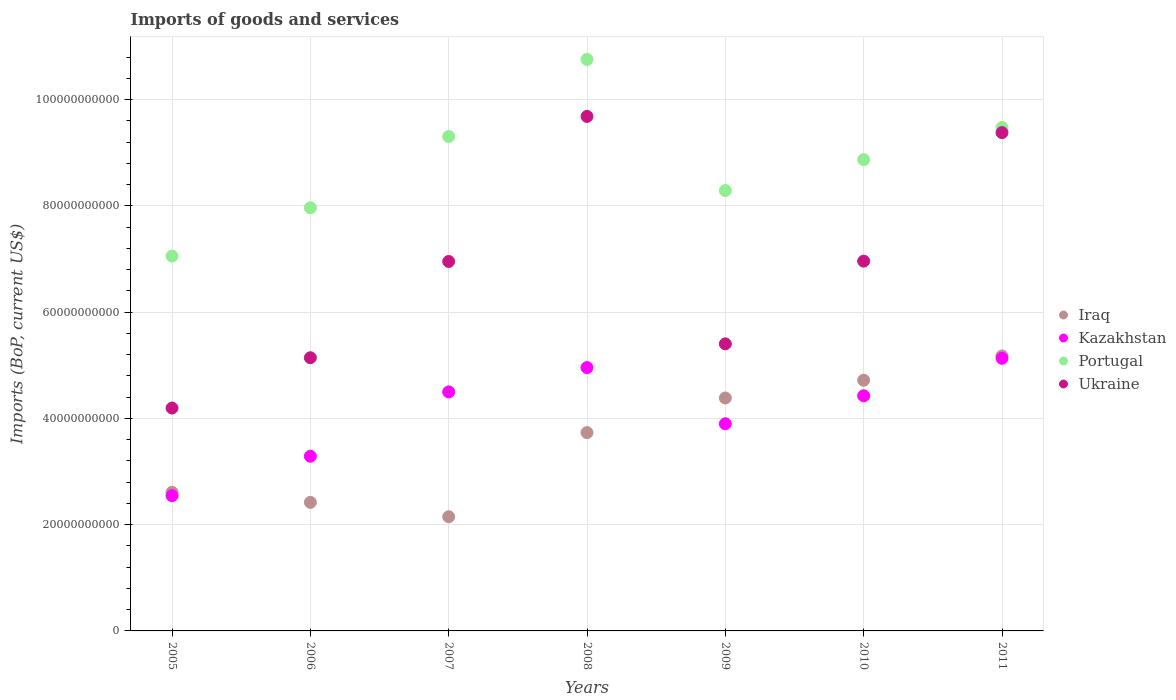How many different coloured dotlines are there?
Ensure brevity in your answer.  4. What is the amount spent on imports in Ukraine in 2008?
Your answer should be very brief. 9.68e+1. Across all years, what is the maximum amount spent on imports in Ukraine?
Your answer should be very brief. 9.68e+1. Across all years, what is the minimum amount spent on imports in Iraq?
Provide a short and direct response. 2.15e+1. In which year was the amount spent on imports in Portugal maximum?
Provide a succinct answer. 2008. In which year was the amount spent on imports in Kazakhstan minimum?
Keep it short and to the point. 2005. What is the total amount spent on imports in Kazakhstan in the graph?
Your response must be concise. 2.87e+11. What is the difference between the amount spent on imports in Kazakhstan in 2007 and that in 2008?
Your response must be concise. -4.58e+09. What is the difference between the amount spent on imports in Portugal in 2005 and the amount spent on imports in Ukraine in 2007?
Make the answer very short. 1.01e+09. What is the average amount spent on imports in Iraq per year?
Your answer should be compact. 3.60e+1. In the year 2008, what is the difference between the amount spent on imports in Iraq and amount spent on imports in Kazakhstan?
Give a very brief answer. -1.22e+1. What is the ratio of the amount spent on imports in Iraq in 2008 to that in 2009?
Ensure brevity in your answer.  0.85. What is the difference between the highest and the second highest amount spent on imports in Ukraine?
Keep it short and to the point. 3.05e+09. What is the difference between the highest and the lowest amount spent on imports in Iraq?
Your answer should be very brief. 3.03e+1. Is the sum of the amount spent on imports in Portugal in 2005 and 2010 greater than the maximum amount spent on imports in Iraq across all years?
Offer a very short reply. Yes. Does the amount spent on imports in Ukraine monotonically increase over the years?
Your answer should be very brief. No. How many dotlines are there?
Ensure brevity in your answer.  4. How many years are there in the graph?
Your response must be concise. 7. Are the values on the major ticks of Y-axis written in scientific E-notation?
Offer a very short reply. No. Does the graph contain grids?
Your response must be concise. Yes. How many legend labels are there?
Offer a very short reply. 4. What is the title of the graph?
Ensure brevity in your answer.  Imports of goods and services. Does "Cambodia" appear as one of the legend labels in the graph?
Provide a succinct answer. No. What is the label or title of the Y-axis?
Your answer should be very brief. Imports (BoP, current US$). What is the Imports (BoP, current US$) in Iraq in 2005?
Make the answer very short. 2.61e+1. What is the Imports (BoP, current US$) of Kazakhstan in 2005?
Offer a very short reply. 2.55e+1. What is the Imports (BoP, current US$) in Portugal in 2005?
Keep it short and to the point. 7.05e+1. What is the Imports (BoP, current US$) in Ukraine in 2005?
Offer a terse response. 4.20e+1. What is the Imports (BoP, current US$) of Iraq in 2006?
Offer a very short reply. 2.42e+1. What is the Imports (BoP, current US$) in Kazakhstan in 2006?
Provide a succinct answer. 3.29e+1. What is the Imports (BoP, current US$) of Portugal in 2006?
Provide a succinct answer. 7.96e+1. What is the Imports (BoP, current US$) of Ukraine in 2006?
Your answer should be very brief. 5.14e+1. What is the Imports (BoP, current US$) of Iraq in 2007?
Your answer should be compact. 2.15e+1. What is the Imports (BoP, current US$) in Kazakhstan in 2007?
Keep it short and to the point. 4.50e+1. What is the Imports (BoP, current US$) of Portugal in 2007?
Provide a short and direct response. 9.31e+1. What is the Imports (BoP, current US$) in Ukraine in 2007?
Your answer should be compact. 6.95e+1. What is the Imports (BoP, current US$) of Iraq in 2008?
Ensure brevity in your answer.  3.73e+1. What is the Imports (BoP, current US$) of Kazakhstan in 2008?
Offer a very short reply. 4.96e+1. What is the Imports (BoP, current US$) of Portugal in 2008?
Give a very brief answer. 1.08e+11. What is the Imports (BoP, current US$) of Ukraine in 2008?
Keep it short and to the point. 9.68e+1. What is the Imports (BoP, current US$) in Iraq in 2009?
Provide a short and direct response. 4.38e+1. What is the Imports (BoP, current US$) of Kazakhstan in 2009?
Make the answer very short. 3.90e+1. What is the Imports (BoP, current US$) in Portugal in 2009?
Provide a short and direct response. 8.29e+1. What is the Imports (BoP, current US$) in Ukraine in 2009?
Your answer should be very brief. 5.40e+1. What is the Imports (BoP, current US$) of Iraq in 2010?
Your response must be concise. 4.72e+1. What is the Imports (BoP, current US$) of Kazakhstan in 2010?
Ensure brevity in your answer.  4.43e+1. What is the Imports (BoP, current US$) in Portugal in 2010?
Offer a very short reply. 8.87e+1. What is the Imports (BoP, current US$) of Ukraine in 2010?
Keep it short and to the point. 6.96e+1. What is the Imports (BoP, current US$) of Iraq in 2011?
Keep it short and to the point. 5.18e+1. What is the Imports (BoP, current US$) of Kazakhstan in 2011?
Offer a very short reply. 5.13e+1. What is the Imports (BoP, current US$) of Portugal in 2011?
Ensure brevity in your answer.  9.48e+1. What is the Imports (BoP, current US$) of Ukraine in 2011?
Your answer should be compact. 9.38e+1. Across all years, what is the maximum Imports (BoP, current US$) in Iraq?
Provide a short and direct response. 5.18e+1. Across all years, what is the maximum Imports (BoP, current US$) of Kazakhstan?
Provide a succinct answer. 5.13e+1. Across all years, what is the maximum Imports (BoP, current US$) of Portugal?
Your answer should be very brief. 1.08e+11. Across all years, what is the maximum Imports (BoP, current US$) in Ukraine?
Your answer should be compact. 9.68e+1. Across all years, what is the minimum Imports (BoP, current US$) in Iraq?
Provide a short and direct response. 2.15e+1. Across all years, what is the minimum Imports (BoP, current US$) of Kazakhstan?
Ensure brevity in your answer.  2.55e+1. Across all years, what is the minimum Imports (BoP, current US$) in Portugal?
Make the answer very short. 7.05e+1. Across all years, what is the minimum Imports (BoP, current US$) of Ukraine?
Your answer should be compact. 4.20e+1. What is the total Imports (BoP, current US$) in Iraq in the graph?
Offer a terse response. 2.52e+11. What is the total Imports (BoP, current US$) in Kazakhstan in the graph?
Keep it short and to the point. 2.87e+11. What is the total Imports (BoP, current US$) of Portugal in the graph?
Offer a very short reply. 6.17e+11. What is the total Imports (BoP, current US$) in Ukraine in the graph?
Keep it short and to the point. 4.77e+11. What is the difference between the Imports (BoP, current US$) of Iraq in 2005 and that in 2006?
Keep it short and to the point. 1.90e+09. What is the difference between the Imports (BoP, current US$) of Kazakhstan in 2005 and that in 2006?
Offer a terse response. -7.42e+09. What is the difference between the Imports (BoP, current US$) of Portugal in 2005 and that in 2006?
Provide a short and direct response. -9.10e+09. What is the difference between the Imports (BoP, current US$) in Ukraine in 2005 and that in 2006?
Your answer should be very brief. -9.47e+09. What is the difference between the Imports (BoP, current US$) of Iraq in 2005 and that in 2007?
Keep it short and to the point. 4.61e+09. What is the difference between the Imports (BoP, current US$) of Kazakhstan in 2005 and that in 2007?
Your answer should be very brief. -1.95e+1. What is the difference between the Imports (BoP, current US$) in Portugal in 2005 and that in 2007?
Provide a short and direct response. -2.25e+1. What is the difference between the Imports (BoP, current US$) of Ukraine in 2005 and that in 2007?
Keep it short and to the point. -2.76e+1. What is the difference between the Imports (BoP, current US$) in Iraq in 2005 and that in 2008?
Ensure brevity in your answer.  -1.12e+1. What is the difference between the Imports (BoP, current US$) of Kazakhstan in 2005 and that in 2008?
Offer a very short reply. -2.41e+1. What is the difference between the Imports (BoP, current US$) in Portugal in 2005 and that in 2008?
Keep it short and to the point. -3.70e+1. What is the difference between the Imports (BoP, current US$) in Ukraine in 2005 and that in 2008?
Offer a terse response. -5.49e+1. What is the difference between the Imports (BoP, current US$) in Iraq in 2005 and that in 2009?
Your response must be concise. -1.78e+1. What is the difference between the Imports (BoP, current US$) of Kazakhstan in 2005 and that in 2009?
Provide a short and direct response. -1.35e+1. What is the difference between the Imports (BoP, current US$) of Portugal in 2005 and that in 2009?
Provide a succinct answer. -1.23e+1. What is the difference between the Imports (BoP, current US$) in Ukraine in 2005 and that in 2009?
Make the answer very short. -1.21e+1. What is the difference between the Imports (BoP, current US$) of Iraq in 2005 and that in 2010?
Offer a terse response. -2.11e+1. What is the difference between the Imports (BoP, current US$) in Kazakhstan in 2005 and that in 2010?
Give a very brief answer. -1.88e+1. What is the difference between the Imports (BoP, current US$) of Portugal in 2005 and that in 2010?
Ensure brevity in your answer.  -1.82e+1. What is the difference between the Imports (BoP, current US$) in Ukraine in 2005 and that in 2010?
Provide a succinct answer. -2.77e+1. What is the difference between the Imports (BoP, current US$) in Iraq in 2005 and that in 2011?
Your answer should be compact. -2.57e+1. What is the difference between the Imports (BoP, current US$) in Kazakhstan in 2005 and that in 2011?
Give a very brief answer. -2.59e+1. What is the difference between the Imports (BoP, current US$) of Portugal in 2005 and that in 2011?
Provide a short and direct response. -2.42e+1. What is the difference between the Imports (BoP, current US$) of Ukraine in 2005 and that in 2011?
Provide a short and direct response. -5.18e+1. What is the difference between the Imports (BoP, current US$) in Iraq in 2006 and that in 2007?
Your response must be concise. 2.71e+09. What is the difference between the Imports (BoP, current US$) in Kazakhstan in 2006 and that in 2007?
Keep it short and to the point. -1.21e+1. What is the difference between the Imports (BoP, current US$) of Portugal in 2006 and that in 2007?
Make the answer very short. -1.34e+1. What is the difference between the Imports (BoP, current US$) of Ukraine in 2006 and that in 2007?
Provide a short and direct response. -1.81e+1. What is the difference between the Imports (BoP, current US$) of Iraq in 2006 and that in 2008?
Your answer should be compact. -1.31e+1. What is the difference between the Imports (BoP, current US$) of Kazakhstan in 2006 and that in 2008?
Give a very brief answer. -1.67e+1. What is the difference between the Imports (BoP, current US$) in Portugal in 2006 and that in 2008?
Make the answer very short. -2.79e+1. What is the difference between the Imports (BoP, current US$) of Ukraine in 2006 and that in 2008?
Make the answer very short. -4.54e+1. What is the difference between the Imports (BoP, current US$) of Iraq in 2006 and that in 2009?
Ensure brevity in your answer.  -1.97e+1. What is the difference between the Imports (BoP, current US$) of Kazakhstan in 2006 and that in 2009?
Your answer should be compact. -6.12e+09. What is the difference between the Imports (BoP, current US$) in Portugal in 2006 and that in 2009?
Give a very brief answer. -3.25e+09. What is the difference between the Imports (BoP, current US$) in Ukraine in 2006 and that in 2009?
Your answer should be very brief. -2.61e+09. What is the difference between the Imports (BoP, current US$) of Iraq in 2006 and that in 2010?
Provide a succinct answer. -2.30e+1. What is the difference between the Imports (BoP, current US$) of Kazakhstan in 2006 and that in 2010?
Your answer should be very brief. -1.14e+1. What is the difference between the Imports (BoP, current US$) of Portugal in 2006 and that in 2010?
Ensure brevity in your answer.  -9.06e+09. What is the difference between the Imports (BoP, current US$) of Ukraine in 2006 and that in 2010?
Provide a succinct answer. -1.82e+1. What is the difference between the Imports (BoP, current US$) of Iraq in 2006 and that in 2011?
Keep it short and to the point. -2.76e+1. What is the difference between the Imports (BoP, current US$) of Kazakhstan in 2006 and that in 2011?
Keep it short and to the point. -1.84e+1. What is the difference between the Imports (BoP, current US$) of Portugal in 2006 and that in 2011?
Offer a terse response. -1.51e+1. What is the difference between the Imports (BoP, current US$) in Ukraine in 2006 and that in 2011?
Your answer should be very brief. -4.24e+1. What is the difference between the Imports (BoP, current US$) of Iraq in 2007 and that in 2008?
Your response must be concise. -1.58e+1. What is the difference between the Imports (BoP, current US$) of Kazakhstan in 2007 and that in 2008?
Your response must be concise. -4.58e+09. What is the difference between the Imports (BoP, current US$) of Portugal in 2007 and that in 2008?
Offer a terse response. -1.45e+1. What is the difference between the Imports (BoP, current US$) of Ukraine in 2007 and that in 2008?
Offer a terse response. -2.73e+1. What is the difference between the Imports (BoP, current US$) in Iraq in 2007 and that in 2009?
Make the answer very short. -2.24e+1. What is the difference between the Imports (BoP, current US$) in Kazakhstan in 2007 and that in 2009?
Your answer should be very brief. 5.99e+09. What is the difference between the Imports (BoP, current US$) of Portugal in 2007 and that in 2009?
Keep it short and to the point. 1.02e+1. What is the difference between the Imports (BoP, current US$) of Ukraine in 2007 and that in 2009?
Your response must be concise. 1.55e+1. What is the difference between the Imports (BoP, current US$) in Iraq in 2007 and that in 2010?
Your response must be concise. -2.57e+1. What is the difference between the Imports (BoP, current US$) of Kazakhstan in 2007 and that in 2010?
Make the answer very short. 7.30e+08. What is the difference between the Imports (BoP, current US$) in Portugal in 2007 and that in 2010?
Your answer should be very brief. 4.36e+09. What is the difference between the Imports (BoP, current US$) of Ukraine in 2007 and that in 2010?
Ensure brevity in your answer.  -6.50e+07. What is the difference between the Imports (BoP, current US$) in Iraq in 2007 and that in 2011?
Offer a very short reply. -3.03e+1. What is the difference between the Imports (BoP, current US$) in Kazakhstan in 2007 and that in 2011?
Offer a terse response. -6.33e+09. What is the difference between the Imports (BoP, current US$) of Portugal in 2007 and that in 2011?
Your response must be concise. -1.70e+09. What is the difference between the Imports (BoP, current US$) in Ukraine in 2007 and that in 2011?
Make the answer very short. -2.43e+1. What is the difference between the Imports (BoP, current US$) in Iraq in 2008 and that in 2009?
Provide a succinct answer. -6.51e+09. What is the difference between the Imports (BoP, current US$) in Kazakhstan in 2008 and that in 2009?
Your answer should be very brief. 1.06e+1. What is the difference between the Imports (BoP, current US$) of Portugal in 2008 and that in 2009?
Make the answer very short. 2.47e+1. What is the difference between the Imports (BoP, current US$) in Ukraine in 2008 and that in 2009?
Give a very brief answer. 4.28e+1. What is the difference between the Imports (BoP, current US$) in Iraq in 2008 and that in 2010?
Provide a succinct answer. -9.86e+09. What is the difference between the Imports (BoP, current US$) of Kazakhstan in 2008 and that in 2010?
Your response must be concise. 5.31e+09. What is the difference between the Imports (BoP, current US$) of Portugal in 2008 and that in 2010?
Your response must be concise. 1.89e+1. What is the difference between the Imports (BoP, current US$) of Ukraine in 2008 and that in 2010?
Your answer should be compact. 2.72e+1. What is the difference between the Imports (BoP, current US$) of Iraq in 2008 and that in 2011?
Your response must be concise. -1.44e+1. What is the difference between the Imports (BoP, current US$) of Kazakhstan in 2008 and that in 2011?
Your answer should be very brief. -1.75e+09. What is the difference between the Imports (BoP, current US$) in Portugal in 2008 and that in 2011?
Make the answer very short. 1.28e+1. What is the difference between the Imports (BoP, current US$) of Ukraine in 2008 and that in 2011?
Offer a terse response. 3.05e+09. What is the difference between the Imports (BoP, current US$) of Iraq in 2009 and that in 2010?
Offer a terse response. -3.34e+09. What is the difference between the Imports (BoP, current US$) in Kazakhstan in 2009 and that in 2010?
Your answer should be compact. -5.26e+09. What is the difference between the Imports (BoP, current US$) in Portugal in 2009 and that in 2010?
Keep it short and to the point. -5.81e+09. What is the difference between the Imports (BoP, current US$) in Ukraine in 2009 and that in 2010?
Give a very brief answer. -1.56e+1. What is the difference between the Imports (BoP, current US$) of Iraq in 2009 and that in 2011?
Keep it short and to the point. -7.91e+09. What is the difference between the Imports (BoP, current US$) of Kazakhstan in 2009 and that in 2011?
Keep it short and to the point. -1.23e+1. What is the difference between the Imports (BoP, current US$) in Portugal in 2009 and that in 2011?
Provide a short and direct response. -1.19e+1. What is the difference between the Imports (BoP, current US$) of Ukraine in 2009 and that in 2011?
Your answer should be very brief. -3.98e+1. What is the difference between the Imports (BoP, current US$) of Iraq in 2010 and that in 2011?
Provide a succinct answer. -4.57e+09. What is the difference between the Imports (BoP, current US$) in Kazakhstan in 2010 and that in 2011?
Provide a short and direct response. -7.06e+09. What is the difference between the Imports (BoP, current US$) of Portugal in 2010 and that in 2011?
Make the answer very short. -6.06e+09. What is the difference between the Imports (BoP, current US$) in Ukraine in 2010 and that in 2011?
Make the answer very short. -2.42e+1. What is the difference between the Imports (BoP, current US$) in Iraq in 2005 and the Imports (BoP, current US$) in Kazakhstan in 2006?
Give a very brief answer. -6.78e+09. What is the difference between the Imports (BoP, current US$) of Iraq in 2005 and the Imports (BoP, current US$) of Portugal in 2006?
Your answer should be compact. -5.36e+1. What is the difference between the Imports (BoP, current US$) of Iraq in 2005 and the Imports (BoP, current US$) of Ukraine in 2006?
Keep it short and to the point. -2.53e+1. What is the difference between the Imports (BoP, current US$) in Kazakhstan in 2005 and the Imports (BoP, current US$) in Portugal in 2006?
Your response must be concise. -5.42e+1. What is the difference between the Imports (BoP, current US$) in Kazakhstan in 2005 and the Imports (BoP, current US$) in Ukraine in 2006?
Provide a short and direct response. -2.60e+1. What is the difference between the Imports (BoP, current US$) of Portugal in 2005 and the Imports (BoP, current US$) of Ukraine in 2006?
Keep it short and to the point. 1.91e+1. What is the difference between the Imports (BoP, current US$) in Iraq in 2005 and the Imports (BoP, current US$) in Kazakhstan in 2007?
Your answer should be very brief. -1.89e+1. What is the difference between the Imports (BoP, current US$) of Iraq in 2005 and the Imports (BoP, current US$) of Portugal in 2007?
Provide a succinct answer. -6.70e+1. What is the difference between the Imports (BoP, current US$) of Iraq in 2005 and the Imports (BoP, current US$) of Ukraine in 2007?
Offer a terse response. -4.34e+1. What is the difference between the Imports (BoP, current US$) of Kazakhstan in 2005 and the Imports (BoP, current US$) of Portugal in 2007?
Your answer should be compact. -6.76e+1. What is the difference between the Imports (BoP, current US$) of Kazakhstan in 2005 and the Imports (BoP, current US$) of Ukraine in 2007?
Keep it short and to the point. -4.41e+1. What is the difference between the Imports (BoP, current US$) in Portugal in 2005 and the Imports (BoP, current US$) in Ukraine in 2007?
Provide a succinct answer. 1.01e+09. What is the difference between the Imports (BoP, current US$) of Iraq in 2005 and the Imports (BoP, current US$) of Kazakhstan in 2008?
Give a very brief answer. -2.35e+1. What is the difference between the Imports (BoP, current US$) in Iraq in 2005 and the Imports (BoP, current US$) in Portugal in 2008?
Your answer should be very brief. -8.15e+1. What is the difference between the Imports (BoP, current US$) of Iraq in 2005 and the Imports (BoP, current US$) of Ukraine in 2008?
Keep it short and to the point. -7.08e+1. What is the difference between the Imports (BoP, current US$) of Kazakhstan in 2005 and the Imports (BoP, current US$) of Portugal in 2008?
Ensure brevity in your answer.  -8.21e+1. What is the difference between the Imports (BoP, current US$) of Kazakhstan in 2005 and the Imports (BoP, current US$) of Ukraine in 2008?
Your answer should be very brief. -7.14e+1. What is the difference between the Imports (BoP, current US$) in Portugal in 2005 and the Imports (BoP, current US$) in Ukraine in 2008?
Make the answer very short. -2.63e+1. What is the difference between the Imports (BoP, current US$) in Iraq in 2005 and the Imports (BoP, current US$) in Kazakhstan in 2009?
Give a very brief answer. -1.29e+1. What is the difference between the Imports (BoP, current US$) of Iraq in 2005 and the Imports (BoP, current US$) of Portugal in 2009?
Make the answer very short. -5.68e+1. What is the difference between the Imports (BoP, current US$) in Iraq in 2005 and the Imports (BoP, current US$) in Ukraine in 2009?
Offer a terse response. -2.79e+1. What is the difference between the Imports (BoP, current US$) in Kazakhstan in 2005 and the Imports (BoP, current US$) in Portugal in 2009?
Your response must be concise. -5.74e+1. What is the difference between the Imports (BoP, current US$) in Kazakhstan in 2005 and the Imports (BoP, current US$) in Ukraine in 2009?
Keep it short and to the point. -2.86e+1. What is the difference between the Imports (BoP, current US$) of Portugal in 2005 and the Imports (BoP, current US$) of Ukraine in 2009?
Offer a terse response. 1.65e+1. What is the difference between the Imports (BoP, current US$) in Iraq in 2005 and the Imports (BoP, current US$) in Kazakhstan in 2010?
Provide a succinct answer. -1.82e+1. What is the difference between the Imports (BoP, current US$) in Iraq in 2005 and the Imports (BoP, current US$) in Portugal in 2010?
Your response must be concise. -6.26e+1. What is the difference between the Imports (BoP, current US$) in Iraq in 2005 and the Imports (BoP, current US$) in Ukraine in 2010?
Give a very brief answer. -4.35e+1. What is the difference between the Imports (BoP, current US$) of Kazakhstan in 2005 and the Imports (BoP, current US$) of Portugal in 2010?
Your answer should be compact. -6.33e+1. What is the difference between the Imports (BoP, current US$) of Kazakhstan in 2005 and the Imports (BoP, current US$) of Ukraine in 2010?
Give a very brief answer. -4.41e+1. What is the difference between the Imports (BoP, current US$) of Portugal in 2005 and the Imports (BoP, current US$) of Ukraine in 2010?
Give a very brief answer. 9.42e+08. What is the difference between the Imports (BoP, current US$) of Iraq in 2005 and the Imports (BoP, current US$) of Kazakhstan in 2011?
Your answer should be very brief. -2.52e+1. What is the difference between the Imports (BoP, current US$) of Iraq in 2005 and the Imports (BoP, current US$) of Portugal in 2011?
Your response must be concise. -6.87e+1. What is the difference between the Imports (BoP, current US$) of Iraq in 2005 and the Imports (BoP, current US$) of Ukraine in 2011?
Your answer should be very brief. -6.77e+1. What is the difference between the Imports (BoP, current US$) of Kazakhstan in 2005 and the Imports (BoP, current US$) of Portugal in 2011?
Offer a very short reply. -6.93e+1. What is the difference between the Imports (BoP, current US$) in Kazakhstan in 2005 and the Imports (BoP, current US$) in Ukraine in 2011?
Provide a short and direct response. -6.83e+1. What is the difference between the Imports (BoP, current US$) in Portugal in 2005 and the Imports (BoP, current US$) in Ukraine in 2011?
Give a very brief answer. -2.32e+1. What is the difference between the Imports (BoP, current US$) in Iraq in 2006 and the Imports (BoP, current US$) in Kazakhstan in 2007?
Provide a short and direct response. -2.08e+1. What is the difference between the Imports (BoP, current US$) of Iraq in 2006 and the Imports (BoP, current US$) of Portugal in 2007?
Your answer should be compact. -6.89e+1. What is the difference between the Imports (BoP, current US$) of Iraq in 2006 and the Imports (BoP, current US$) of Ukraine in 2007?
Provide a succinct answer. -4.53e+1. What is the difference between the Imports (BoP, current US$) of Kazakhstan in 2006 and the Imports (BoP, current US$) of Portugal in 2007?
Provide a short and direct response. -6.02e+1. What is the difference between the Imports (BoP, current US$) in Kazakhstan in 2006 and the Imports (BoP, current US$) in Ukraine in 2007?
Ensure brevity in your answer.  -3.67e+1. What is the difference between the Imports (BoP, current US$) in Portugal in 2006 and the Imports (BoP, current US$) in Ukraine in 2007?
Your answer should be compact. 1.01e+1. What is the difference between the Imports (BoP, current US$) of Iraq in 2006 and the Imports (BoP, current US$) of Kazakhstan in 2008?
Keep it short and to the point. -2.54e+1. What is the difference between the Imports (BoP, current US$) in Iraq in 2006 and the Imports (BoP, current US$) in Portugal in 2008?
Offer a terse response. -8.34e+1. What is the difference between the Imports (BoP, current US$) of Iraq in 2006 and the Imports (BoP, current US$) of Ukraine in 2008?
Provide a short and direct response. -7.27e+1. What is the difference between the Imports (BoP, current US$) in Kazakhstan in 2006 and the Imports (BoP, current US$) in Portugal in 2008?
Make the answer very short. -7.47e+1. What is the difference between the Imports (BoP, current US$) in Kazakhstan in 2006 and the Imports (BoP, current US$) in Ukraine in 2008?
Make the answer very short. -6.40e+1. What is the difference between the Imports (BoP, current US$) of Portugal in 2006 and the Imports (BoP, current US$) of Ukraine in 2008?
Offer a very short reply. -1.72e+1. What is the difference between the Imports (BoP, current US$) of Iraq in 2006 and the Imports (BoP, current US$) of Kazakhstan in 2009?
Keep it short and to the point. -1.48e+1. What is the difference between the Imports (BoP, current US$) in Iraq in 2006 and the Imports (BoP, current US$) in Portugal in 2009?
Keep it short and to the point. -5.87e+1. What is the difference between the Imports (BoP, current US$) in Iraq in 2006 and the Imports (BoP, current US$) in Ukraine in 2009?
Provide a short and direct response. -2.98e+1. What is the difference between the Imports (BoP, current US$) in Kazakhstan in 2006 and the Imports (BoP, current US$) in Portugal in 2009?
Your answer should be compact. -5.00e+1. What is the difference between the Imports (BoP, current US$) of Kazakhstan in 2006 and the Imports (BoP, current US$) of Ukraine in 2009?
Provide a succinct answer. -2.12e+1. What is the difference between the Imports (BoP, current US$) in Portugal in 2006 and the Imports (BoP, current US$) in Ukraine in 2009?
Provide a short and direct response. 2.56e+1. What is the difference between the Imports (BoP, current US$) of Iraq in 2006 and the Imports (BoP, current US$) of Kazakhstan in 2010?
Provide a short and direct response. -2.01e+1. What is the difference between the Imports (BoP, current US$) in Iraq in 2006 and the Imports (BoP, current US$) in Portugal in 2010?
Provide a succinct answer. -6.45e+1. What is the difference between the Imports (BoP, current US$) in Iraq in 2006 and the Imports (BoP, current US$) in Ukraine in 2010?
Give a very brief answer. -4.54e+1. What is the difference between the Imports (BoP, current US$) in Kazakhstan in 2006 and the Imports (BoP, current US$) in Portugal in 2010?
Offer a very short reply. -5.58e+1. What is the difference between the Imports (BoP, current US$) of Kazakhstan in 2006 and the Imports (BoP, current US$) of Ukraine in 2010?
Provide a short and direct response. -3.67e+1. What is the difference between the Imports (BoP, current US$) of Portugal in 2006 and the Imports (BoP, current US$) of Ukraine in 2010?
Keep it short and to the point. 1.00e+1. What is the difference between the Imports (BoP, current US$) in Iraq in 2006 and the Imports (BoP, current US$) in Kazakhstan in 2011?
Your answer should be compact. -2.71e+1. What is the difference between the Imports (BoP, current US$) of Iraq in 2006 and the Imports (BoP, current US$) of Portugal in 2011?
Provide a succinct answer. -7.06e+1. What is the difference between the Imports (BoP, current US$) of Iraq in 2006 and the Imports (BoP, current US$) of Ukraine in 2011?
Your answer should be compact. -6.96e+1. What is the difference between the Imports (BoP, current US$) in Kazakhstan in 2006 and the Imports (BoP, current US$) in Portugal in 2011?
Your answer should be compact. -6.19e+1. What is the difference between the Imports (BoP, current US$) of Kazakhstan in 2006 and the Imports (BoP, current US$) of Ukraine in 2011?
Provide a short and direct response. -6.09e+1. What is the difference between the Imports (BoP, current US$) of Portugal in 2006 and the Imports (BoP, current US$) of Ukraine in 2011?
Offer a very short reply. -1.41e+1. What is the difference between the Imports (BoP, current US$) of Iraq in 2007 and the Imports (BoP, current US$) of Kazakhstan in 2008?
Provide a succinct answer. -2.81e+1. What is the difference between the Imports (BoP, current US$) in Iraq in 2007 and the Imports (BoP, current US$) in Portugal in 2008?
Make the answer very short. -8.61e+1. What is the difference between the Imports (BoP, current US$) of Iraq in 2007 and the Imports (BoP, current US$) of Ukraine in 2008?
Your response must be concise. -7.54e+1. What is the difference between the Imports (BoP, current US$) in Kazakhstan in 2007 and the Imports (BoP, current US$) in Portugal in 2008?
Provide a succinct answer. -6.26e+1. What is the difference between the Imports (BoP, current US$) in Kazakhstan in 2007 and the Imports (BoP, current US$) in Ukraine in 2008?
Your answer should be very brief. -5.19e+1. What is the difference between the Imports (BoP, current US$) in Portugal in 2007 and the Imports (BoP, current US$) in Ukraine in 2008?
Your response must be concise. -3.78e+09. What is the difference between the Imports (BoP, current US$) of Iraq in 2007 and the Imports (BoP, current US$) of Kazakhstan in 2009?
Offer a terse response. -1.75e+1. What is the difference between the Imports (BoP, current US$) of Iraq in 2007 and the Imports (BoP, current US$) of Portugal in 2009?
Your response must be concise. -6.14e+1. What is the difference between the Imports (BoP, current US$) of Iraq in 2007 and the Imports (BoP, current US$) of Ukraine in 2009?
Make the answer very short. -3.25e+1. What is the difference between the Imports (BoP, current US$) of Kazakhstan in 2007 and the Imports (BoP, current US$) of Portugal in 2009?
Keep it short and to the point. -3.79e+1. What is the difference between the Imports (BoP, current US$) of Kazakhstan in 2007 and the Imports (BoP, current US$) of Ukraine in 2009?
Offer a terse response. -9.05e+09. What is the difference between the Imports (BoP, current US$) in Portugal in 2007 and the Imports (BoP, current US$) in Ukraine in 2009?
Provide a short and direct response. 3.90e+1. What is the difference between the Imports (BoP, current US$) of Iraq in 2007 and the Imports (BoP, current US$) of Kazakhstan in 2010?
Your response must be concise. -2.28e+1. What is the difference between the Imports (BoP, current US$) in Iraq in 2007 and the Imports (BoP, current US$) in Portugal in 2010?
Provide a succinct answer. -6.72e+1. What is the difference between the Imports (BoP, current US$) in Iraq in 2007 and the Imports (BoP, current US$) in Ukraine in 2010?
Give a very brief answer. -4.81e+1. What is the difference between the Imports (BoP, current US$) in Kazakhstan in 2007 and the Imports (BoP, current US$) in Portugal in 2010?
Keep it short and to the point. -4.37e+1. What is the difference between the Imports (BoP, current US$) of Kazakhstan in 2007 and the Imports (BoP, current US$) of Ukraine in 2010?
Ensure brevity in your answer.  -2.46e+1. What is the difference between the Imports (BoP, current US$) of Portugal in 2007 and the Imports (BoP, current US$) of Ukraine in 2010?
Your answer should be compact. 2.35e+1. What is the difference between the Imports (BoP, current US$) of Iraq in 2007 and the Imports (BoP, current US$) of Kazakhstan in 2011?
Your response must be concise. -2.98e+1. What is the difference between the Imports (BoP, current US$) of Iraq in 2007 and the Imports (BoP, current US$) of Portugal in 2011?
Your answer should be compact. -7.33e+1. What is the difference between the Imports (BoP, current US$) in Iraq in 2007 and the Imports (BoP, current US$) in Ukraine in 2011?
Offer a terse response. -7.23e+1. What is the difference between the Imports (BoP, current US$) in Kazakhstan in 2007 and the Imports (BoP, current US$) in Portugal in 2011?
Your answer should be compact. -4.98e+1. What is the difference between the Imports (BoP, current US$) of Kazakhstan in 2007 and the Imports (BoP, current US$) of Ukraine in 2011?
Your response must be concise. -4.88e+1. What is the difference between the Imports (BoP, current US$) in Portugal in 2007 and the Imports (BoP, current US$) in Ukraine in 2011?
Offer a terse response. -7.29e+08. What is the difference between the Imports (BoP, current US$) in Iraq in 2008 and the Imports (BoP, current US$) in Kazakhstan in 2009?
Ensure brevity in your answer.  -1.67e+09. What is the difference between the Imports (BoP, current US$) of Iraq in 2008 and the Imports (BoP, current US$) of Portugal in 2009?
Your answer should be very brief. -4.56e+1. What is the difference between the Imports (BoP, current US$) of Iraq in 2008 and the Imports (BoP, current US$) of Ukraine in 2009?
Make the answer very short. -1.67e+1. What is the difference between the Imports (BoP, current US$) in Kazakhstan in 2008 and the Imports (BoP, current US$) in Portugal in 2009?
Offer a terse response. -3.33e+1. What is the difference between the Imports (BoP, current US$) in Kazakhstan in 2008 and the Imports (BoP, current US$) in Ukraine in 2009?
Provide a succinct answer. -4.47e+09. What is the difference between the Imports (BoP, current US$) in Portugal in 2008 and the Imports (BoP, current US$) in Ukraine in 2009?
Offer a very short reply. 5.35e+1. What is the difference between the Imports (BoP, current US$) of Iraq in 2008 and the Imports (BoP, current US$) of Kazakhstan in 2010?
Provide a short and direct response. -6.93e+09. What is the difference between the Imports (BoP, current US$) of Iraq in 2008 and the Imports (BoP, current US$) of Portugal in 2010?
Your answer should be compact. -5.14e+1. What is the difference between the Imports (BoP, current US$) of Iraq in 2008 and the Imports (BoP, current US$) of Ukraine in 2010?
Give a very brief answer. -3.23e+1. What is the difference between the Imports (BoP, current US$) in Kazakhstan in 2008 and the Imports (BoP, current US$) in Portugal in 2010?
Keep it short and to the point. -3.91e+1. What is the difference between the Imports (BoP, current US$) of Kazakhstan in 2008 and the Imports (BoP, current US$) of Ukraine in 2010?
Provide a succinct answer. -2.00e+1. What is the difference between the Imports (BoP, current US$) in Portugal in 2008 and the Imports (BoP, current US$) in Ukraine in 2010?
Offer a very short reply. 3.80e+1. What is the difference between the Imports (BoP, current US$) in Iraq in 2008 and the Imports (BoP, current US$) in Kazakhstan in 2011?
Provide a short and direct response. -1.40e+1. What is the difference between the Imports (BoP, current US$) of Iraq in 2008 and the Imports (BoP, current US$) of Portugal in 2011?
Offer a terse response. -5.74e+1. What is the difference between the Imports (BoP, current US$) of Iraq in 2008 and the Imports (BoP, current US$) of Ukraine in 2011?
Provide a succinct answer. -5.65e+1. What is the difference between the Imports (BoP, current US$) in Kazakhstan in 2008 and the Imports (BoP, current US$) in Portugal in 2011?
Provide a short and direct response. -4.52e+1. What is the difference between the Imports (BoP, current US$) in Kazakhstan in 2008 and the Imports (BoP, current US$) in Ukraine in 2011?
Ensure brevity in your answer.  -4.42e+1. What is the difference between the Imports (BoP, current US$) of Portugal in 2008 and the Imports (BoP, current US$) of Ukraine in 2011?
Provide a short and direct response. 1.38e+1. What is the difference between the Imports (BoP, current US$) of Iraq in 2009 and the Imports (BoP, current US$) of Kazakhstan in 2010?
Keep it short and to the point. -4.12e+08. What is the difference between the Imports (BoP, current US$) of Iraq in 2009 and the Imports (BoP, current US$) of Portugal in 2010?
Keep it short and to the point. -4.49e+1. What is the difference between the Imports (BoP, current US$) of Iraq in 2009 and the Imports (BoP, current US$) of Ukraine in 2010?
Your response must be concise. -2.58e+1. What is the difference between the Imports (BoP, current US$) of Kazakhstan in 2009 and the Imports (BoP, current US$) of Portugal in 2010?
Offer a terse response. -4.97e+1. What is the difference between the Imports (BoP, current US$) of Kazakhstan in 2009 and the Imports (BoP, current US$) of Ukraine in 2010?
Make the answer very short. -3.06e+1. What is the difference between the Imports (BoP, current US$) in Portugal in 2009 and the Imports (BoP, current US$) in Ukraine in 2010?
Give a very brief answer. 1.33e+1. What is the difference between the Imports (BoP, current US$) of Iraq in 2009 and the Imports (BoP, current US$) of Kazakhstan in 2011?
Offer a very short reply. -7.47e+09. What is the difference between the Imports (BoP, current US$) of Iraq in 2009 and the Imports (BoP, current US$) of Portugal in 2011?
Ensure brevity in your answer.  -5.09e+1. What is the difference between the Imports (BoP, current US$) in Iraq in 2009 and the Imports (BoP, current US$) in Ukraine in 2011?
Give a very brief answer. -4.99e+1. What is the difference between the Imports (BoP, current US$) in Kazakhstan in 2009 and the Imports (BoP, current US$) in Portugal in 2011?
Make the answer very short. -5.58e+1. What is the difference between the Imports (BoP, current US$) of Kazakhstan in 2009 and the Imports (BoP, current US$) of Ukraine in 2011?
Your answer should be compact. -5.48e+1. What is the difference between the Imports (BoP, current US$) in Portugal in 2009 and the Imports (BoP, current US$) in Ukraine in 2011?
Make the answer very short. -1.09e+1. What is the difference between the Imports (BoP, current US$) in Iraq in 2010 and the Imports (BoP, current US$) in Kazakhstan in 2011?
Make the answer very short. -4.13e+09. What is the difference between the Imports (BoP, current US$) in Iraq in 2010 and the Imports (BoP, current US$) in Portugal in 2011?
Your answer should be compact. -4.76e+1. What is the difference between the Imports (BoP, current US$) of Iraq in 2010 and the Imports (BoP, current US$) of Ukraine in 2011?
Offer a terse response. -4.66e+1. What is the difference between the Imports (BoP, current US$) in Kazakhstan in 2010 and the Imports (BoP, current US$) in Portugal in 2011?
Your response must be concise. -5.05e+1. What is the difference between the Imports (BoP, current US$) of Kazakhstan in 2010 and the Imports (BoP, current US$) of Ukraine in 2011?
Make the answer very short. -4.95e+1. What is the difference between the Imports (BoP, current US$) of Portugal in 2010 and the Imports (BoP, current US$) of Ukraine in 2011?
Give a very brief answer. -5.09e+09. What is the average Imports (BoP, current US$) of Iraq per year?
Ensure brevity in your answer.  3.60e+1. What is the average Imports (BoP, current US$) of Kazakhstan per year?
Give a very brief answer. 4.11e+1. What is the average Imports (BoP, current US$) in Portugal per year?
Your answer should be very brief. 8.82e+1. What is the average Imports (BoP, current US$) of Ukraine per year?
Keep it short and to the point. 6.82e+1. In the year 2005, what is the difference between the Imports (BoP, current US$) in Iraq and Imports (BoP, current US$) in Kazakhstan?
Keep it short and to the point. 6.38e+08. In the year 2005, what is the difference between the Imports (BoP, current US$) in Iraq and Imports (BoP, current US$) in Portugal?
Provide a short and direct response. -4.45e+1. In the year 2005, what is the difference between the Imports (BoP, current US$) in Iraq and Imports (BoP, current US$) in Ukraine?
Provide a succinct answer. -1.59e+1. In the year 2005, what is the difference between the Imports (BoP, current US$) of Kazakhstan and Imports (BoP, current US$) of Portugal?
Your answer should be compact. -4.51e+1. In the year 2005, what is the difference between the Imports (BoP, current US$) in Kazakhstan and Imports (BoP, current US$) in Ukraine?
Provide a succinct answer. -1.65e+1. In the year 2005, what is the difference between the Imports (BoP, current US$) of Portugal and Imports (BoP, current US$) of Ukraine?
Offer a very short reply. 2.86e+1. In the year 2006, what is the difference between the Imports (BoP, current US$) of Iraq and Imports (BoP, current US$) of Kazakhstan?
Make the answer very short. -8.68e+09. In the year 2006, what is the difference between the Imports (BoP, current US$) of Iraq and Imports (BoP, current US$) of Portugal?
Provide a short and direct response. -5.55e+1. In the year 2006, what is the difference between the Imports (BoP, current US$) of Iraq and Imports (BoP, current US$) of Ukraine?
Ensure brevity in your answer.  -2.72e+1. In the year 2006, what is the difference between the Imports (BoP, current US$) of Kazakhstan and Imports (BoP, current US$) of Portugal?
Make the answer very short. -4.68e+1. In the year 2006, what is the difference between the Imports (BoP, current US$) in Kazakhstan and Imports (BoP, current US$) in Ukraine?
Give a very brief answer. -1.85e+1. In the year 2006, what is the difference between the Imports (BoP, current US$) in Portugal and Imports (BoP, current US$) in Ukraine?
Your response must be concise. 2.82e+1. In the year 2007, what is the difference between the Imports (BoP, current US$) of Iraq and Imports (BoP, current US$) of Kazakhstan?
Give a very brief answer. -2.35e+1. In the year 2007, what is the difference between the Imports (BoP, current US$) in Iraq and Imports (BoP, current US$) in Portugal?
Provide a short and direct response. -7.16e+1. In the year 2007, what is the difference between the Imports (BoP, current US$) of Iraq and Imports (BoP, current US$) of Ukraine?
Give a very brief answer. -4.81e+1. In the year 2007, what is the difference between the Imports (BoP, current US$) of Kazakhstan and Imports (BoP, current US$) of Portugal?
Ensure brevity in your answer.  -4.81e+1. In the year 2007, what is the difference between the Imports (BoP, current US$) in Kazakhstan and Imports (BoP, current US$) in Ukraine?
Provide a short and direct response. -2.46e+1. In the year 2007, what is the difference between the Imports (BoP, current US$) in Portugal and Imports (BoP, current US$) in Ukraine?
Give a very brief answer. 2.35e+1. In the year 2008, what is the difference between the Imports (BoP, current US$) in Iraq and Imports (BoP, current US$) in Kazakhstan?
Give a very brief answer. -1.22e+1. In the year 2008, what is the difference between the Imports (BoP, current US$) of Iraq and Imports (BoP, current US$) of Portugal?
Make the answer very short. -7.02e+1. In the year 2008, what is the difference between the Imports (BoP, current US$) in Iraq and Imports (BoP, current US$) in Ukraine?
Make the answer very short. -5.95e+1. In the year 2008, what is the difference between the Imports (BoP, current US$) of Kazakhstan and Imports (BoP, current US$) of Portugal?
Make the answer very short. -5.80e+1. In the year 2008, what is the difference between the Imports (BoP, current US$) of Kazakhstan and Imports (BoP, current US$) of Ukraine?
Your answer should be compact. -4.73e+1. In the year 2008, what is the difference between the Imports (BoP, current US$) in Portugal and Imports (BoP, current US$) in Ukraine?
Offer a terse response. 1.07e+1. In the year 2009, what is the difference between the Imports (BoP, current US$) of Iraq and Imports (BoP, current US$) of Kazakhstan?
Your response must be concise. 4.85e+09. In the year 2009, what is the difference between the Imports (BoP, current US$) of Iraq and Imports (BoP, current US$) of Portugal?
Your answer should be compact. -3.90e+1. In the year 2009, what is the difference between the Imports (BoP, current US$) of Iraq and Imports (BoP, current US$) of Ukraine?
Provide a short and direct response. -1.02e+1. In the year 2009, what is the difference between the Imports (BoP, current US$) of Kazakhstan and Imports (BoP, current US$) of Portugal?
Your answer should be very brief. -4.39e+1. In the year 2009, what is the difference between the Imports (BoP, current US$) of Kazakhstan and Imports (BoP, current US$) of Ukraine?
Provide a short and direct response. -1.50e+1. In the year 2009, what is the difference between the Imports (BoP, current US$) in Portugal and Imports (BoP, current US$) in Ukraine?
Offer a terse response. 2.89e+1. In the year 2010, what is the difference between the Imports (BoP, current US$) of Iraq and Imports (BoP, current US$) of Kazakhstan?
Make the answer very short. 2.93e+09. In the year 2010, what is the difference between the Imports (BoP, current US$) in Iraq and Imports (BoP, current US$) in Portugal?
Your answer should be very brief. -4.15e+1. In the year 2010, what is the difference between the Imports (BoP, current US$) of Iraq and Imports (BoP, current US$) of Ukraine?
Give a very brief answer. -2.24e+1. In the year 2010, what is the difference between the Imports (BoP, current US$) of Kazakhstan and Imports (BoP, current US$) of Portugal?
Provide a short and direct response. -4.45e+1. In the year 2010, what is the difference between the Imports (BoP, current US$) of Kazakhstan and Imports (BoP, current US$) of Ukraine?
Ensure brevity in your answer.  -2.53e+1. In the year 2010, what is the difference between the Imports (BoP, current US$) of Portugal and Imports (BoP, current US$) of Ukraine?
Your answer should be very brief. 1.91e+1. In the year 2011, what is the difference between the Imports (BoP, current US$) of Iraq and Imports (BoP, current US$) of Kazakhstan?
Make the answer very short. 4.34e+08. In the year 2011, what is the difference between the Imports (BoP, current US$) of Iraq and Imports (BoP, current US$) of Portugal?
Ensure brevity in your answer.  -4.30e+1. In the year 2011, what is the difference between the Imports (BoP, current US$) in Iraq and Imports (BoP, current US$) in Ukraine?
Provide a short and direct response. -4.20e+1. In the year 2011, what is the difference between the Imports (BoP, current US$) of Kazakhstan and Imports (BoP, current US$) of Portugal?
Your answer should be very brief. -4.34e+1. In the year 2011, what is the difference between the Imports (BoP, current US$) in Kazakhstan and Imports (BoP, current US$) in Ukraine?
Ensure brevity in your answer.  -4.25e+1. In the year 2011, what is the difference between the Imports (BoP, current US$) in Portugal and Imports (BoP, current US$) in Ukraine?
Your response must be concise. 9.73e+08. What is the ratio of the Imports (BoP, current US$) of Iraq in 2005 to that in 2006?
Provide a short and direct response. 1.08. What is the ratio of the Imports (BoP, current US$) of Kazakhstan in 2005 to that in 2006?
Your response must be concise. 0.77. What is the ratio of the Imports (BoP, current US$) of Portugal in 2005 to that in 2006?
Offer a very short reply. 0.89. What is the ratio of the Imports (BoP, current US$) in Ukraine in 2005 to that in 2006?
Provide a succinct answer. 0.82. What is the ratio of the Imports (BoP, current US$) of Iraq in 2005 to that in 2007?
Ensure brevity in your answer.  1.21. What is the ratio of the Imports (BoP, current US$) in Kazakhstan in 2005 to that in 2007?
Provide a succinct answer. 0.57. What is the ratio of the Imports (BoP, current US$) in Portugal in 2005 to that in 2007?
Keep it short and to the point. 0.76. What is the ratio of the Imports (BoP, current US$) of Ukraine in 2005 to that in 2007?
Give a very brief answer. 0.6. What is the ratio of the Imports (BoP, current US$) of Iraq in 2005 to that in 2008?
Give a very brief answer. 0.7. What is the ratio of the Imports (BoP, current US$) of Kazakhstan in 2005 to that in 2008?
Give a very brief answer. 0.51. What is the ratio of the Imports (BoP, current US$) in Portugal in 2005 to that in 2008?
Provide a succinct answer. 0.66. What is the ratio of the Imports (BoP, current US$) in Ukraine in 2005 to that in 2008?
Provide a short and direct response. 0.43. What is the ratio of the Imports (BoP, current US$) of Iraq in 2005 to that in 2009?
Your response must be concise. 0.6. What is the ratio of the Imports (BoP, current US$) of Kazakhstan in 2005 to that in 2009?
Keep it short and to the point. 0.65. What is the ratio of the Imports (BoP, current US$) in Portugal in 2005 to that in 2009?
Keep it short and to the point. 0.85. What is the ratio of the Imports (BoP, current US$) of Ukraine in 2005 to that in 2009?
Your response must be concise. 0.78. What is the ratio of the Imports (BoP, current US$) in Iraq in 2005 to that in 2010?
Provide a succinct answer. 0.55. What is the ratio of the Imports (BoP, current US$) in Kazakhstan in 2005 to that in 2010?
Your answer should be very brief. 0.58. What is the ratio of the Imports (BoP, current US$) of Portugal in 2005 to that in 2010?
Offer a very short reply. 0.8. What is the ratio of the Imports (BoP, current US$) in Ukraine in 2005 to that in 2010?
Ensure brevity in your answer.  0.6. What is the ratio of the Imports (BoP, current US$) of Iraq in 2005 to that in 2011?
Provide a short and direct response. 0.5. What is the ratio of the Imports (BoP, current US$) in Kazakhstan in 2005 to that in 2011?
Provide a short and direct response. 0.5. What is the ratio of the Imports (BoP, current US$) in Portugal in 2005 to that in 2011?
Give a very brief answer. 0.74. What is the ratio of the Imports (BoP, current US$) in Ukraine in 2005 to that in 2011?
Provide a short and direct response. 0.45. What is the ratio of the Imports (BoP, current US$) in Iraq in 2006 to that in 2007?
Your answer should be very brief. 1.13. What is the ratio of the Imports (BoP, current US$) in Kazakhstan in 2006 to that in 2007?
Ensure brevity in your answer.  0.73. What is the ratio of the Imports (BoP, current US$) in Portugal in 2006 to that in 2007?
Offer a very short reply. 0.86. What is the ratio of the Imports (BoP, current US$) in Ukraine in 2006 to that in 2007?
Give a very brief answer. 0.74. What is the ratio of the Imports (BoP, current US$) of Iraq in 2006 to that in 2008?
Keep it short and to the point. 0.65. What is the ratio of the Imports (BoP, current US$) in Kazakhstan in 2006 to that in 2008?
Offer a terse response. 0.66. What is the ratio of the Imports (BoP, current US$) in Portugal in 2006 to that in 2008?
Provide a short and direct response. 0.74. What is the ratio of the Imports (BoP, current US$) of Ukraine in 2006 to that in 2008?
Your answer should be compact. 0.53. What is the ratio of the Imports (BoP, current US$) in Iraq in 2006 to that in 2009?
Give a very brief answer. 0.55. What is the ratio of the Imports (BoP, current US$) of Kazakhstan in 2006 to that in 2009?
Your answer should be very brief. 0.84. What is the ratio of the Imports (BoP, current US$) in Portugal in 2006 to that in 2009?
Your answer should be very brief. 0.96. What is the ratio of the Imports (BoP, current US$) in Ukraine in 2006 to that in 2009?
Your answer should be very brief. 0.95. What is the ratio of the Imports (BoP, current US$) of Iraq in 2006 to that in 2010?
Offer a very short reply. 0.51. What is the ratio of the Imports (BoP, current US$) in Kazakhstan in 2006 to that in 2010?
Give a very brief answer. 0.74. What is the ratio of the Imports (BoP, current US$) of Portugal in 2006 to that in 2010?
Offer a very short reply. 0.9. What is the ratio of the Imports (BoP, current US$) in Ukraine in 2006 to that in 2010?
Your response must be concise. 0.74. What is the ratio of the Imports (BoP, current US$) of Iraq in 2006 to that in 2011?
Give a very brief answer. 0.47. What is the ratio of the Imports (BoP, current US$) of Kazakhstan in 2006 to that in 2011?
Keep it short and to the point. 0.64. What is the ratio of the Imports (BoP, current US$) in Portugal in 2006 to that in 2011?
Keep it short and to the point. 0.84. What is the ratio of the Imports (BoP, current US$) of Ukraine in 2006 to that in 2011?
Give a very brief answer. 0.55. What is the ratio of the Imports (BoP, current US$) in Iraq in 2007 to that in 2008?
Ensure brevity in your answer.  0.58. What is the ratio of the Imports (BoP, current US$) of Kazakhstan in 2007 to that in 2008?
Your response must be concise. 0.91. What is the ratio of the Imports (BoP, current US$) of Portugal in 2007 to that in 2008?
Ensure brevity in your answer.  0.87. What is the ratio of the Imports (BoP, current US$) of Ukraine in 2007 to that in 2008?
Your answer should be compact. 0.72. What is the ratio of the Imports (BoP, current US$) of Iraq in 2007 to that in 2009?
Provide a short and direct response. 0.49. What is the ratio of the Imports (BoP, current US$) of Kazakhstan in 2007 to that in 2009?
Give a very brief answer. 1.15. What is the ratio of the Imports (BoP, current US$) in Portugal in 2007 to that in 2009?
Offer a very short reply. 1.12. What is the ratio of the Imports (BoP, current US$) of Ukraine in 2007 to that in 2009?
Offer a terse response. 1.29. What is the ratio of the Imports (BoP, current US$) in Iraq in 2007 to that in 2010?
Offer a very short reply. 0.46. What is the ratio of the Imports (BoP, current US$) of Kazakhstan in 2007 to that in 2010?
Provide a short and direct response. 1.02. What is the ratio of the Imports (BoP, current US$) of Portugal in 2007 to that in 2010?
Ensure brevity in your answer.  1.05. What is the ratio of the Imports (BoP, current US$) of Iraq in 2007 to that in 2011?
Make the answer very short. 0.42. What is the ratio of the Imports (BoP, current US$) of Kazakhstan in 2007 to that in 2011?
Ensure brevity in your answer.  0.88. What is the ratio of the Imports (BoP, current US$) in Ukraine in 2007 to that in 2011?
Provide a short and direct response. 0.74. What is the ratio of the Imports (BoP, current US$) of Iraq in 2008 to that in 2009?
Ensure brevity in your answer.  0.85. What is the ratio of the Imports (BoP, current US$) in Kazakhstan in 2008 to that in 2009?
Your answer should be compact. 1.27. What is the ratio of the Imports (BoP, current US$) in Portugal in 2008 to that in 2009?
Ensure brevity in your answer.  1.3. What is the ratio of the Imports (BoP, current US$) of Ukraine in 2008 to that in 2009?
Your answer should be compact. 1.79. What is the ratio of the Imports (BoP, current US$) of Iraq in 2008 to that in 2010?
Offer a very short reply. 0.79. What is the ratio of the Imports (BoP, current US$) in Kazakhstan in 2008 to that in 2010?
Ensure brevity in your answer.  1.12. What is the ratio of the Imports (BoP, current US$) in Portugal in 2008 to that in 2010?
Your response must be concise. 1.21. What is the ratio of the Imports (BoP, current US$) of Ukraine in 2008 to that in 2010?
Your answer should be very brief. 1.39. What is the ratio of the Imports (BoP, current US$) of Iraq in 2008 to that in 2011?
Your response must be concise. 0.72. What is the ratio of the Imports (BoP, current US$) in Kazakhstan in 2008 to that in 2011?
Make the answer very short. 0.97. What is the ratio of the Imports (BoP, current US$) of Portugal in 2008 to that in 2011?
Provide a short and direct response. 1.14. What is the ratio of the Imports (BoP, current US$) of Ukraine in 2008 to that in 2011?
Ensure brevity in your answer.  1.03. What is the ratio of the Imports (BoP, current US$) in Iraq in 2009 to that in 2010?
Your answer should be very brief. 0.93. What is the ratio of the Imports (BoP, current US$) of Kazakhstan in 2009 to that in 2010?
Make the answer very short. 0.88. What is the ratio of the Imports (BoP, current US$) in Portugal in 2009 to that in 2010?
Offer a terse response. 0.93. What is the ratio of the Imports (BoP, current US$) of Ukraine in 2009 to that in 2010?
Keep it short and to the point. 0.78. What is the ratio of the Imports (BoP, current US$) of Iraq in 2009 to that in 2011?
Your response must be concise. 0.85. What is the ratio of the Imports (BoP, current US$) in Kazakhstan in 2009 to that in 2011?
Give a very brief answer. 0.76. What is the ratio of the Imports (BoP, current US$) of Portugal in 2009 to that in 2011?
Your answer should be very brief. 0.87. What is the ratio of the Imports (BoP, current US$) of Ukraine in 2009 to that in 2011?
Your answer should be very brief. 0.58. What is the ratio of the Imports (BoP, current US$) in Iraq in 2010 to that in 2011?
Your answer should be very brief. 0.91. What is the ratio of the Imports (BoP, current US$) in Kazakhstan in 2010 to that in 2011?
Ensure brevity in your answer.  0.86. What is the ratio of the Imports (BoP, current US$) of Portugal in 2010 to that in 2011?
Your response must be concise. 0.94. What is the ratio of the Imports (BoP, current US$) of Ukraine in 2010 to that in 2011?
Offer a terse response. 0.74. What is the difference between the highest and the second highest Imports (BoP, current US$) of Iraq?
Offer a very short reply. 4.57e+09. What is the difference between the highest and the second highest Imports (BoP, current US$) in Kazakhstan?
Make the answer very short. 1.75e+09. What is the difference between the highest and the second highest Imports (BoP, current US$) in Portugal?
Provide a succinct answer. 1.28e+1. What is the difference between the highest and the second highest Imports (BoP, current US$) in Ukraine?
Your response must be concise. 3.05e+09. What is the difference between the highest and the lowest Imports (BoP, current US$) of Iraq?
Your answer should be compact. 3.03e+1. What is the difference between the highest and the lowest Imports (BoP, current US$) of Kazakhstan?
Offer a terse response. 2.59e+1. What is the difference between the highest and the lowest Imports (BoP, current US$) of Portugal?
Offer a very short reply. 3.70e+1. What is the difference between the highest and the lowest Imports (BoP, current US$) in Ukraine?
Ensure brevity in your answer.  5.49e+1. 